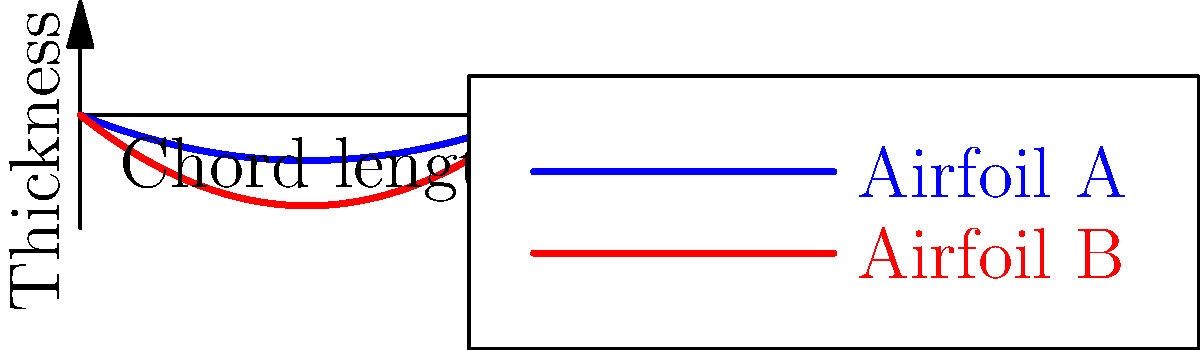In the context of cultural decision-making in aircraft design, consider the flow patterns around two different airfoil shapes, A and B, as shown in the graph. If a society values fuel efficiency in their aircraft, which airfoil shape would likely be preferred, and how might this preference reflect broader cultural values? To answer this question, we need to analyze the airfoil shapes and their implications for aerodynamics and fuel efficiency:

1. Shape analysis:
   - Airfoil A (blue) has a thinner profile
   - Airfoil B (red) has a thicker profile

2. Aerodynamic principles:
   - Thinner airfoils generally produce less drag
   - Less drag translates to better fuel efficiency

3. Performance implications:
   - Airfoil A would likely be more fuel-efficient due to reduced drag
   - Airfoil B might provide more lift but at the cost of increased drag

4. Cultural implications:
   - A society valuing fuel efficiency would likely prefer Airfoil A
   - This preference reflects values such as:
     a) Environmental consciousness
     b) Resource conservation
     c) Economic pragmatism

5. Broader cultural analysis:
   - The choice of Airfoil A might indicate:
     a) A culture that prioritizes long-term sustainability
     b) A society with limited fuel resources or high fuel costs
     c) A culture that values technological innovation for efficiency

6. Decision-making process:
   - The choice between airfoils involves balancing multiple factors:
     a) Fuel efficiency vs. lift capacity
     b) Environmental impact vs. performance
     c) Economic considerations vs. technical capabilities

This analysis demonstrates how technical decisions in aircraft design can reflect and reinforce broader cultural values and priorities.
Answer: Airfoil A, reflecting values of efficiency, sustainability, and resource conservation. 